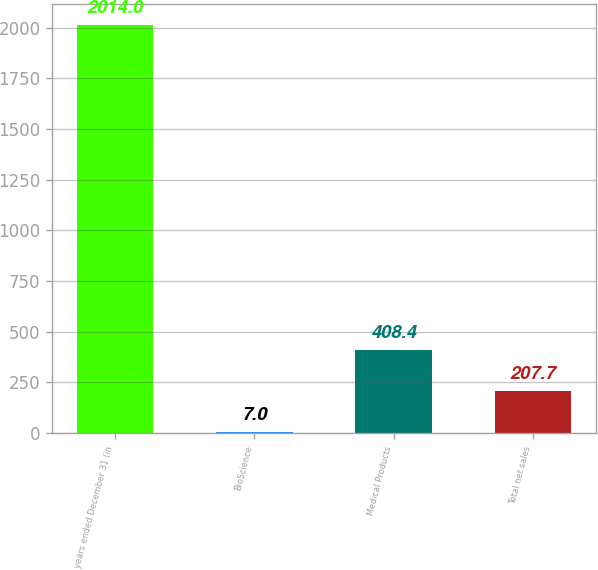<chart> <loc_0><loc_0><loc_500><loc_500><bar_chart><fcel>years ended December 31 (in<fcel>BioScience<fcel>Medical Products<fcel>Total net sales<nl><fcel>2014<fcel>7<fcel>408.4<fcel>207.7<nl></chart> 